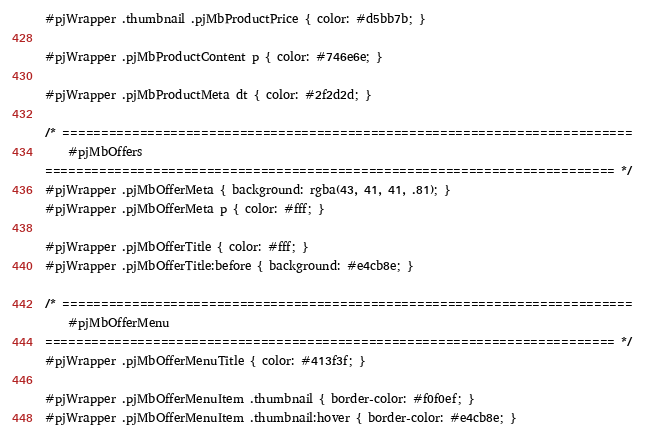Convert code to text. <code><loc_0><loc_0><loc_500><loc_500><_CSS_>#pjWrapper .thumbnail .pjMbProductPrice { color: #d5bb7b; }

#pjWrapper .pjMbProductContent p { color: #746e6e; }

#pjWrapper .pjMbProductMeta dt { color: #2f2d2d; }

/* ==========================================================================
	#pjMbOffers
========================================================================== */
#pjWrapper .pjMbOfferMeta { background: rgba(43, 41, 41, .81); }
#pjWrapper .pjMbOfferMeta p { color: #fff; }

#pjWrapper .pjMbOfferTitle { color: #fff; }
#pjWrapper .pjMbOfferTitle:before { background: #e4cb8e; }

/* ==========================================================================
	#pjMbOfferMenu
========================================================================== */
#pjWrapper .pjMbOfferMenuTitle { color: #413f3f; }

#pjWrapper .pjMbOfferMenuItem .thumbnail { border-color: #f0f0ef; }
#pjWrapper .pjMbOfferMenuItem .thumbnail:hover { border-color: #e4cb8e; }
</code> 